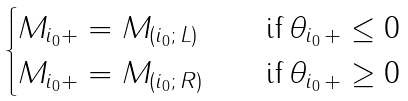Convert formula to latex. <formula><loc_0><loc_0><loc_500><loc_500>\begin{cases} M _ { i _ { 0 } + } = M _ { ( i _ { 0 } ; \, L ) } \quad & \text {if} \, \theta _ { i _ { 0 } \, + } \leq 0 \\ M _ { i _ { 0 } + } = M _ { ( i _ { 0 } ; \, R ) } \quad & \text {if} \, \theta _ { i _ { 0 } \, + } \geq 0 \end{cases}</formula> 